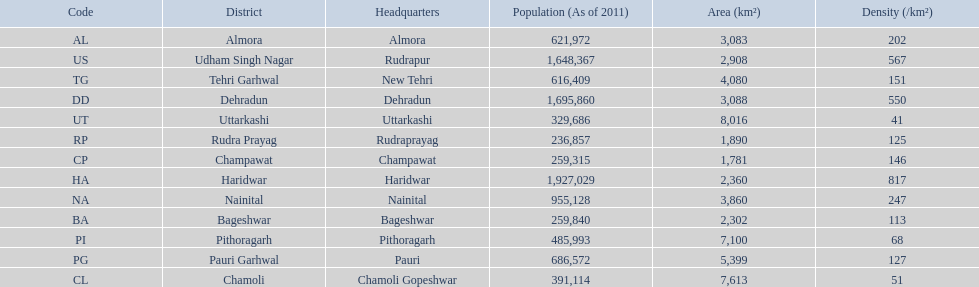What are the values for density of the districts of uttrakhand? 202, 113, 51, 146, 550, 817, 247, 127, 68, 125, 151, 567, 41. Which district has value of 51? Chamoli. 